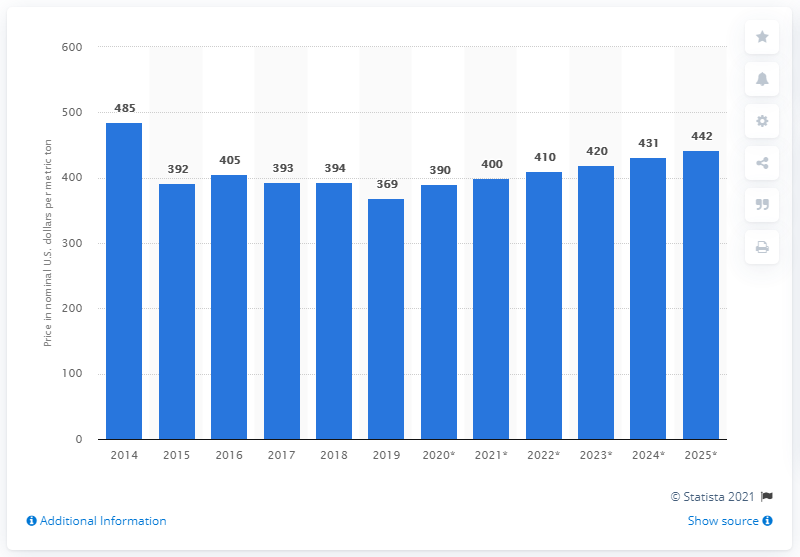Indicate a few pertinent items in this graphic. The average price per metric ton for soybeans in 2019 was 369. 